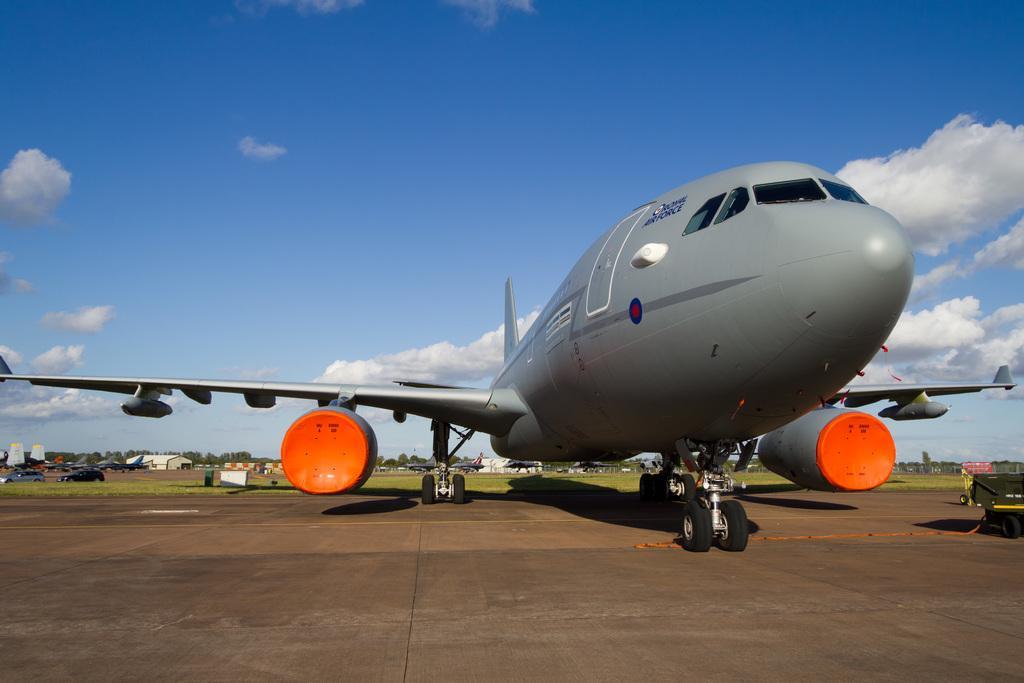Please provide a concise description of this image. In this image I can see an aircraft and the aircraft is in gray and orange color. Background I can see few vehicles, buildings, trees in green color and the sky is in blue and white color. 